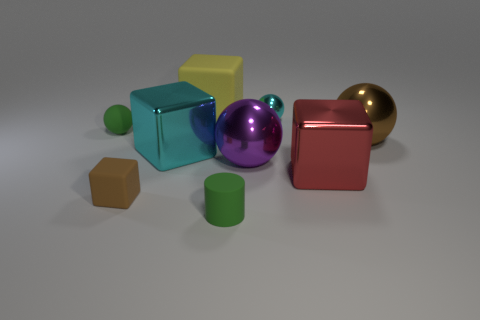There is a small ball that is on the left side of the green object in front of the brown matte thing; what is its material?
Provide a succinct answer. Rubber. Is the material of the small green object in front of the large red object the same as the tiny brown thing?
Make the answer very short. Yes. There is a green thing that is behind the small green rubber cylinder; what is its size?
Provide a short and direct response. Small. There is a tiny green thing on the right side of the big cyan shiny cube; are there any purple things on the right side of it?
Give a very brief answer. Yes. Is the color of the tiny matte object that is behind the large cyan thing the same as the tiny matte object that is on the right side of the large rubber block?
Provide a succinct answer. Yes. The small cylinder is what color?
Provide a short and direct response. Green. Is there anything else that has the same color as the small shiny ball?
Your response must be concise. Yes. There is a small thing that is right of the large yellow block and behind the large red block; what is its color?
Provide a succinct answer. Cyan. There is a cube that is on the right side of the purple thing; does it have the same size as the purple metallic thing?
Ensure brevity in your answer.  Yes. Is the number of green things that are in front of the brown rubber thing greater than the number of yellow spheres?
Your response must be concise. Yes. 